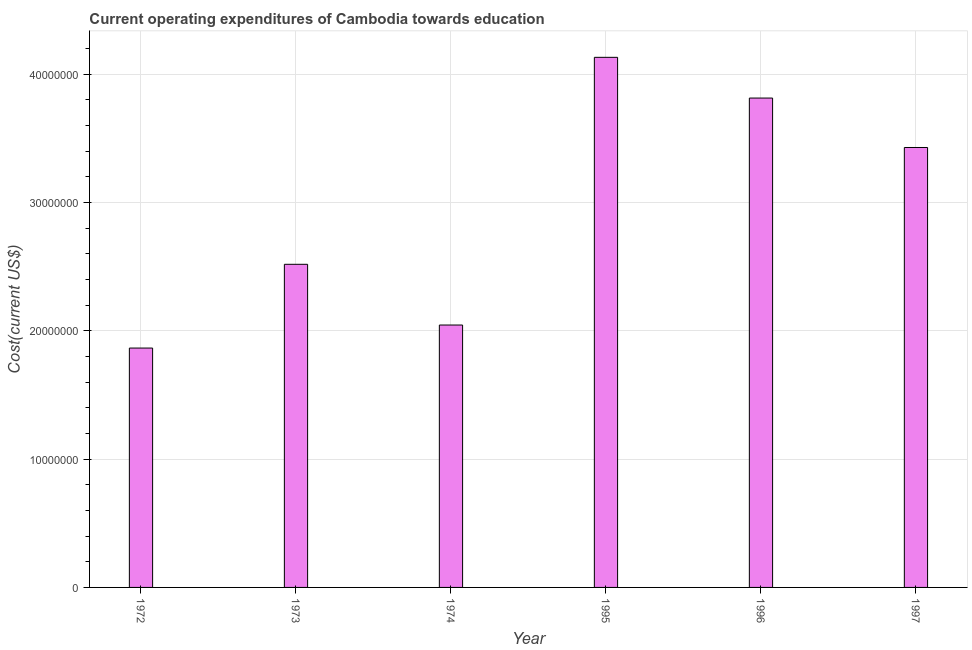Does the graph contain any zero values?
Your response must be concise. No. Does the graph contain grids?
Provide a short and direct response. Yes. What is the title of the graph?
Give a very brief answer. Current operating expenditures of Cambodia towards education. What is the label or title of the X-axis?
Offer a terse response. Year. What is the label or title of the Y-axis?
Your response must be concise. Cost(current US$). What is the education expenditure in 1972?
Make the answer very short. 1.87e+07. Across all years, what is the maximum education expenditure?
Your response must be concise. 4.13e+07. Across all years, what is the minimum education expenditure?
Keep it short and to the point. 1.87e+07. In which year was the education expenditure maximum?
Provide a succinct answer. 1995. What is the sum of the education expenditure?
Your answer should be very brief. 1.78e+08. What is the difference between the education expenditure in 1974 and 1996?
Provide a succinct answer. -1.77e+07. What is the average education expenditure per year?
Your answer should be compact. 2.97e+07. What is the median education expenditure?
Your answer should be compact. 2.97e+07. What is the ratio of the education expenditure in 1973 to that in 1996?
Provide a short and direct response. 0.66. What is the difference between the highest and the second highest education expenditure?
Give a very brief answer. 3.17e+06. Is the sum of the education expenditure in 1995 and 1996 greater than the maximum education expenditure across all years?
Your response must be concise. Yes. What is the difference between the highest and the lowest education expenditure?
Your response must be concise. 2.27e+07. In how many years, is the education expenditure greater than the average education expenditure taken over all years?
Your answer should be very brief. 3. How many bars are there?
Your answer should be compact. 6. How many years are there in the graph?
Give a very brief answer. 6. What is the difference between two consecutive major ticks on the Y-axis?
Give a very brief answer. 1.00e+07. What is the Cost(current US$) of 1972?
Provide a succinct answer. 1.87e+07. What is the Cost(current US$) of 1973?
Offer a very short reply. 2.52e+07. What is the Cost(current US$) in 1974?
Your answer should be very brief. 2.05e+07. What is the Cost(current US$) in 1995?
Offer a terse response. 4.13e+07. What is the Cost(current US$) in 1996?
Offer a very short reply. 3.81e+07. What is the Cost(current US$) of 1997?
Provide a succinct answer. 3.43e+07. What is the difference between the Cost(current US$) in 1972 and 1973?
Provide a succinct answer. -6.53e+06. What is the difference between the Cost(current US$) in 1972 and 1974?
Provide a succinct answer. -1.80e+06. What is the difference between the Cost(current US$) in 1972 and 1995?
Offer a very short reply. -2.27e+07. What is the difference between the Cost(current US$) in 1972 and 1996?
Provide a succinct answer. -1.95e+07. What is the difference between the Cost(current US$) in 1972 and 1997?
Your response must be concise. -1.56e+07. What is the difference between the Cost(current US$) in 1973 and 1974?
Give a very brief answer. 4.73e+06. What is the difference between the Cost(current US$) in 1973 and 1995?
Your answer should be very brief. -1.61e+07. What is the difference between the Cost(current US$) in 1973 and 1996?
Provide a short and direct response. -1.30e+07. What is the difference between the Cost(current US$) in 1973 and 1997?
Make the answer very short. -9.10e+06. What is the difference between the Cost(current US$) in 1974 and 1995?
Ensure brevity in your answer.  -2.09e+07. What is the difference between the Cost(current US$) in 1974 and 1996?
Give a very brief answer. -1.77e+07. What is the difference between the Cost(current US$) in 1974 and 1997?
Make the answer very short. -1.38e+07. What is the difference between the Cost(current US$) in 1995 and 1996?
Your response must be concise. 3.17e+06. What is the difference between the Cost(current US$) in 1995 and 1997?
Provide a succinct answer. 7.03e+06. What is the difference between the Cost(current US$) in 1996 and 1997?
Keep it short and to the point. 3.85e+06. What is the ratio of the Cost(current US$) in 1972 to that in 1973?
Make the answer very short. 0.74. What is the ratio of the Cost(current US$) in 1972 to that in 1974?
Provide a succinct answer. 0.91. What is the ratio of the Cost(current US$) in 1972 to that in 1995?
Ensure brevity in your answer.  0.45. What is the ratio of the Cost(current US$) in 1972 to that in 1996?
Give a very brief answer. 0.49. What is the ratio of the Cost(current US$) in 1972 to that in 1997?
Make the answer very short. 0.54. What is the ratio of the Cost(current US$) in 1973 to that in 1974?
Offer a terse response. 1.23. What is the ratio of the Cost(current US$) in 1973 to that in 1995?
Your answer should be compact. 0.61. What is the ratio of the Cost(current US$) in 1973 to that in 1996?
Your answer should be compact. 0.66. What is the ratio of the Cost(current US$) in 1973 to that in 1997?
Offer a very short reply. 0.73. What is the ratio of the Cost(current US$) in 1974 to that in 1995?
Provide a short and direct response. 0.49. What is the ratio of the Cost(current US$) in 1974 to that in 1996?
Ensure brevity in your answer.  0.54. What is the ratio of the Cost(current US$) in 1974 to that in 1997?
Offer a very short reply. 0.6. What is the ratio of the Cost(current US$) in 1995 to that in 1996?
Your answer should be compact. 1.08. What is the ratio of the Cost(current US$) in 1995 to that in 1997?
Provide a short and direct response. 1.21. What is the ratio of the Cost(current US$) in 1996 to that in 1997?
Keep it short and to the point. 1.11. 